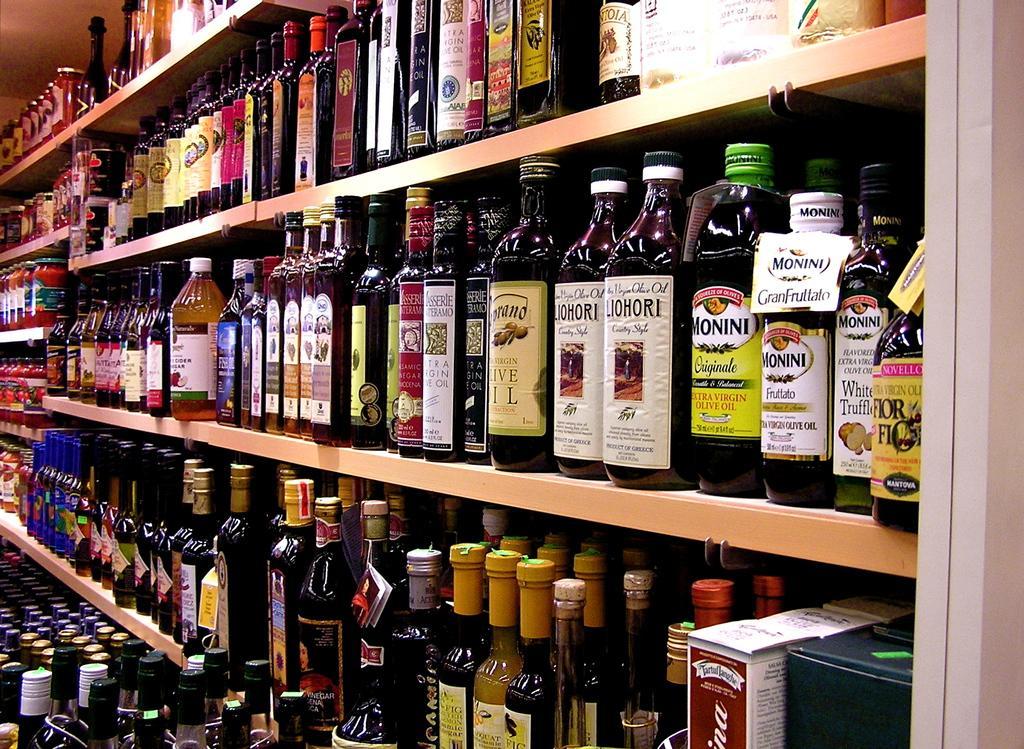Could you give a brief overview of what you see in this image? This image contains shelves having bottles arranged in it. 